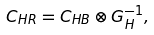<formula> <loc_0><loc_0><loc_500><loc_500>C _ { H R } = C _ { H B } \otimes G _ { H } ^ { - 1 } ,</formula> 